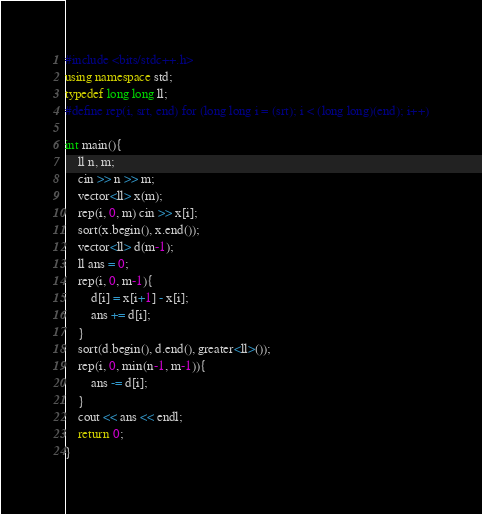<code> <loc_0><loc_0><loc_500><loc_500><_C++_>#include <bits/stdc++.h>
using namespace std;
typedef long long ll;
#define rep(i, srt, end) for (long long i = (srt); i < (long long)(end); i++)

int main(){
    ll n, m;
    cin >> n >> m;
    vector<ll> x(m);
    rep(i, 0, m) cin >> x[i];
    sort(x.begin(), x.end());
    vector<ll> d(m-1);
    ll ans = 0;
    rep(i, 0, m-1){
        d[i] = x[i+1] - x[i];
        ans += d[i];
    }
    sort(d.begin(), d.end(), greater<ll>());
    rep(i, 0, min(n-1, m-1)){
        ans -= d[i];
    }
    cout << ans << endl;
    return 0;
}</code> 